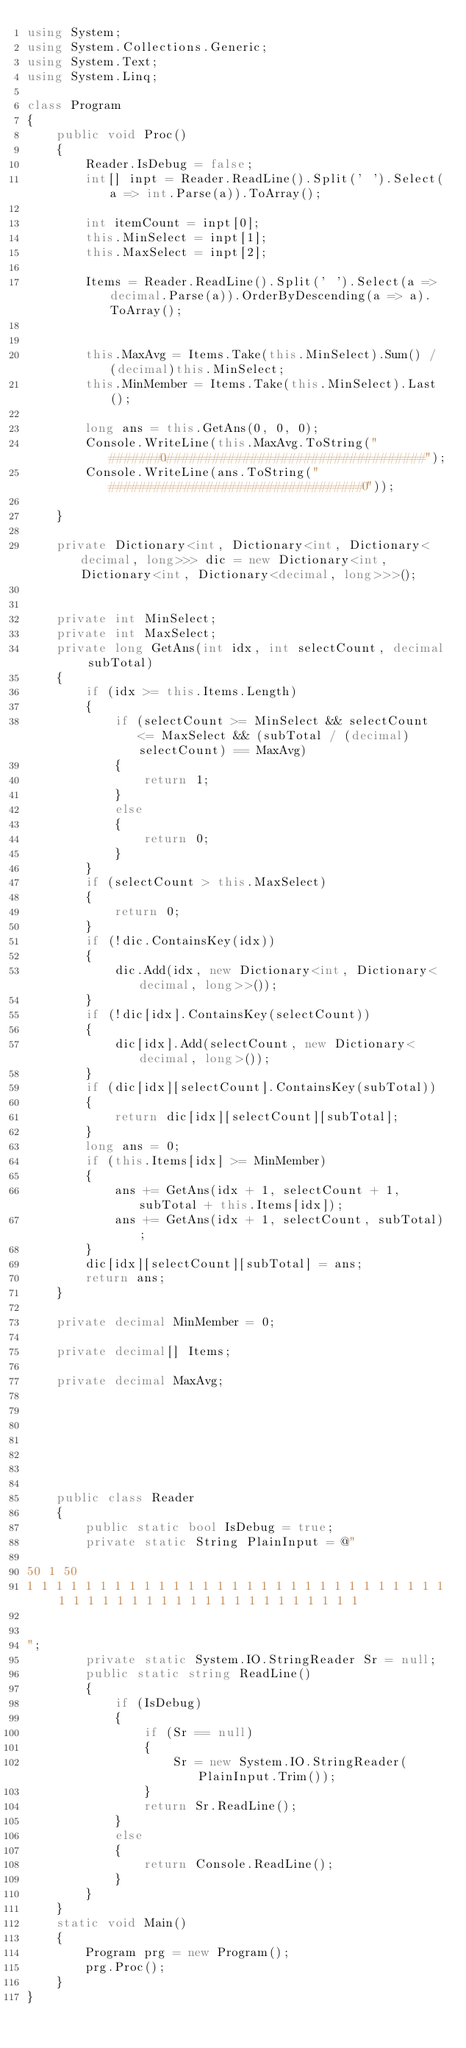Convert code to text. <code><loc_0><loc_0><loc_500><loc_500><_C#_>using System;
using System.Collections.Generic;
using System.Text;
using System.Linq;

class Program
{
    public void Proc()
    {
        Reader.IsDebug = false;
        int[] inpt = Reader.ReadLine().Split(' ').Select(a => int.Parse(a)).ToArray();

        int itemCount = inpt[0];
        this.MinSelect = inpt[1];
        this.MaxSelect = inpt[2];

        Items = Reader.ReadLine().Split(' ').Select(a => decimal.Parse(a)).OrderByDescending(a => a).ToArray();


        this.MaxAvg = Items.Take(this.MinSelect).Sum() / (decimal)this.MinSelect;
        this.MinMember = Items.Take(this.MinSelect).Last();

        long ans = this.GetAns(0, 0, 0);
        Console.WriteLine(this.MaxAvg.ToString("#######0.##################################");
        Console.WriteLine(ans.ToString("##################################0"));

    }

    private Dictionary<int, Dictionary<int, Dictionary<decimal, long>>> dic = new Dictionary<int, Dictionary<int, Dictionary<decimal, long>>>();


    private int MinSelect;
    private int MaxSelect;
    private long GetAns(int idx, int selectCount, decimal subTotal)
    {
        if (idx >= this.Items.Length)
        {
            if (selectCount >= MinSelect && selectCount <= MaxSelect && (subTotal / (decimal)selectCount) == MaxAvg)
            {
                return 1;
            }
            else
            {
                return 0;
            }
        }
        if (selectCount > this.MaxSelect)
        {
            return 0;
        }
        if (!dic.ContainsKey(idx))
        {
            dic.Add(idx, new Dictionary<int, Dictionary<decimal, long>>());
        }
        if (!dic[idx].ContainsKey(selectCount))
        {
            dic[idx].Add(selectCount, new Dictionary<decimal, long>());
        }
        if (dic[idx][selectCount].ContainsKey(subTotal))
        {
            return dic[idx][selectCount][subTotal];
        }
        long ans = 0;
        if (this.Items[idx] >= MinMember)
        {
            ans += GetAns(idx + 1, selectCount + 1, subTotal + this.Items[idx]);
            ans += GetAns(idx + 1, selectCount, subTotal);
        }
        dic[idx][selectCount][subTotal] = ans;
        return ans;
    }

    private decimal MinMember = 0;

    private decimal[] Items;

    private decimal MaxAvg;







    public class Reader
    {
        public static bool IsDebug = true;
        private static String PlainInput = @"

50 1 50
1 1 1 1 1 1 1 1 1 1 1 1 1 1 1 1 1 1 1 1 1 1 1 1 1 1 1 1 1 1 1 1 1 1 1 1 1 1 1 1 1 1 1 1 1 1 1 1 1 1


";
        private static System.IO.StringReader Sr = null;
        public static string ReadLine()
        {
            if (IsDebug)
            {
                if (Sr == null)
                {
                    Sr = new System.IO.StringReader(PlainInput.Trim());
                }
                return Sr.ReadLine();
            }
            else
            {
                return Console.ReadLine();
            }
        }
    }
    static void Main()
    {
        Program prg = new Program();
        prg.Proc();
    }
}</code> 